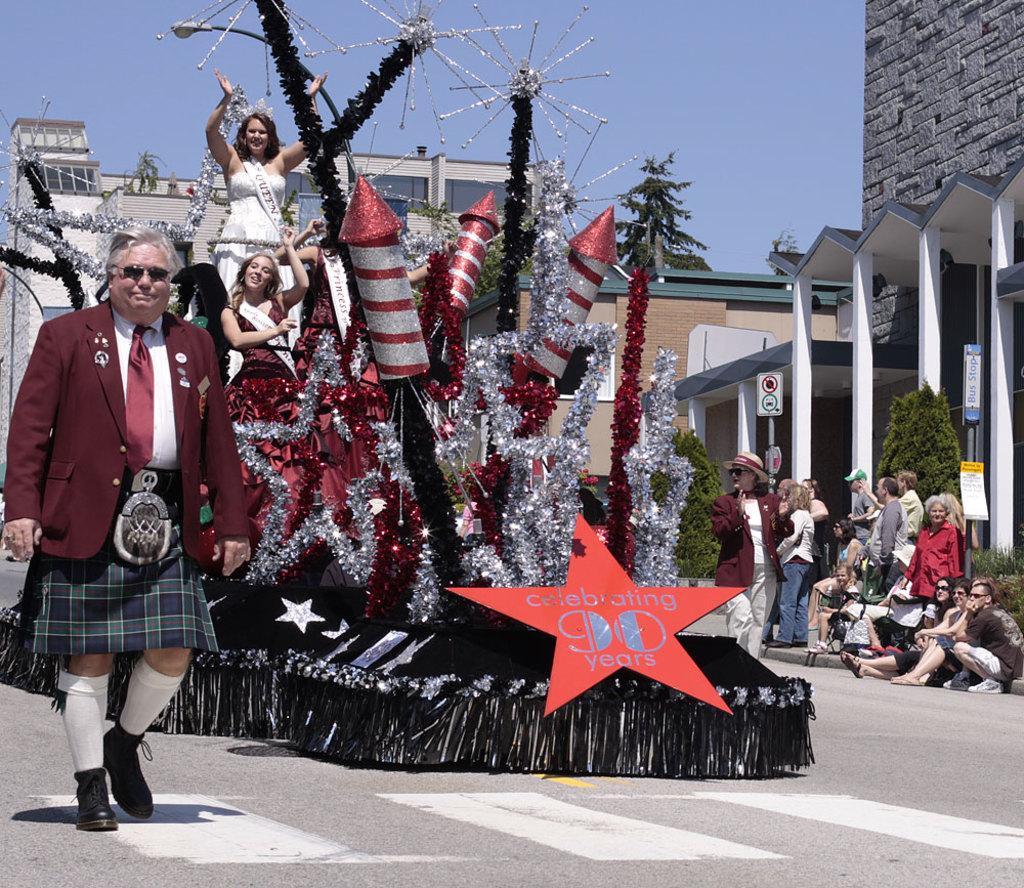Can you describe this image briefly? In this image we can see a person wearing red color suit and skirt walking on the road there are some persons standing on the vehicle which is decorated with stars and rockets and on the right side of the image there are some persons sitting and standing near the house and in the background of the image there are some houses and clear sky. 